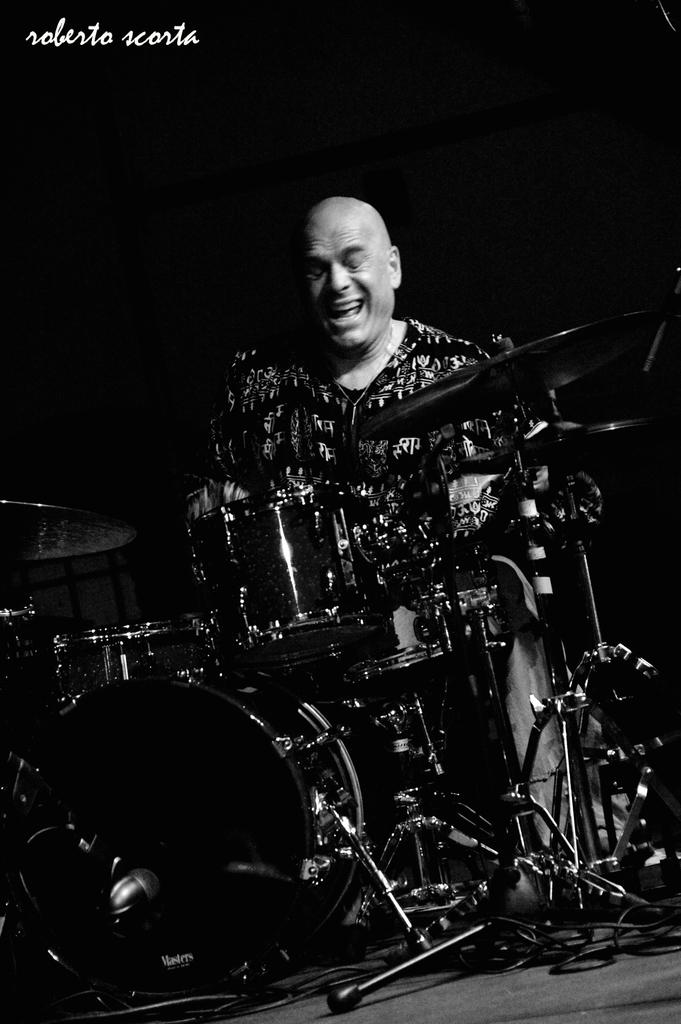What is the main subject of the image? The main subject of the image is a person. What is the person doing in the image? The person is playing musical instruments. Can you describe the background of the image? The background of the image is dark. How many bones can be seen in the image? There are no bones visible in the image. Are there any ants crawling on the person playing musical instruments? There are no ants present in the image. 